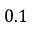Convert formula to latex. <formula><loc_0><loc_0><loc_500><loc_500>0 . 1</formula> 